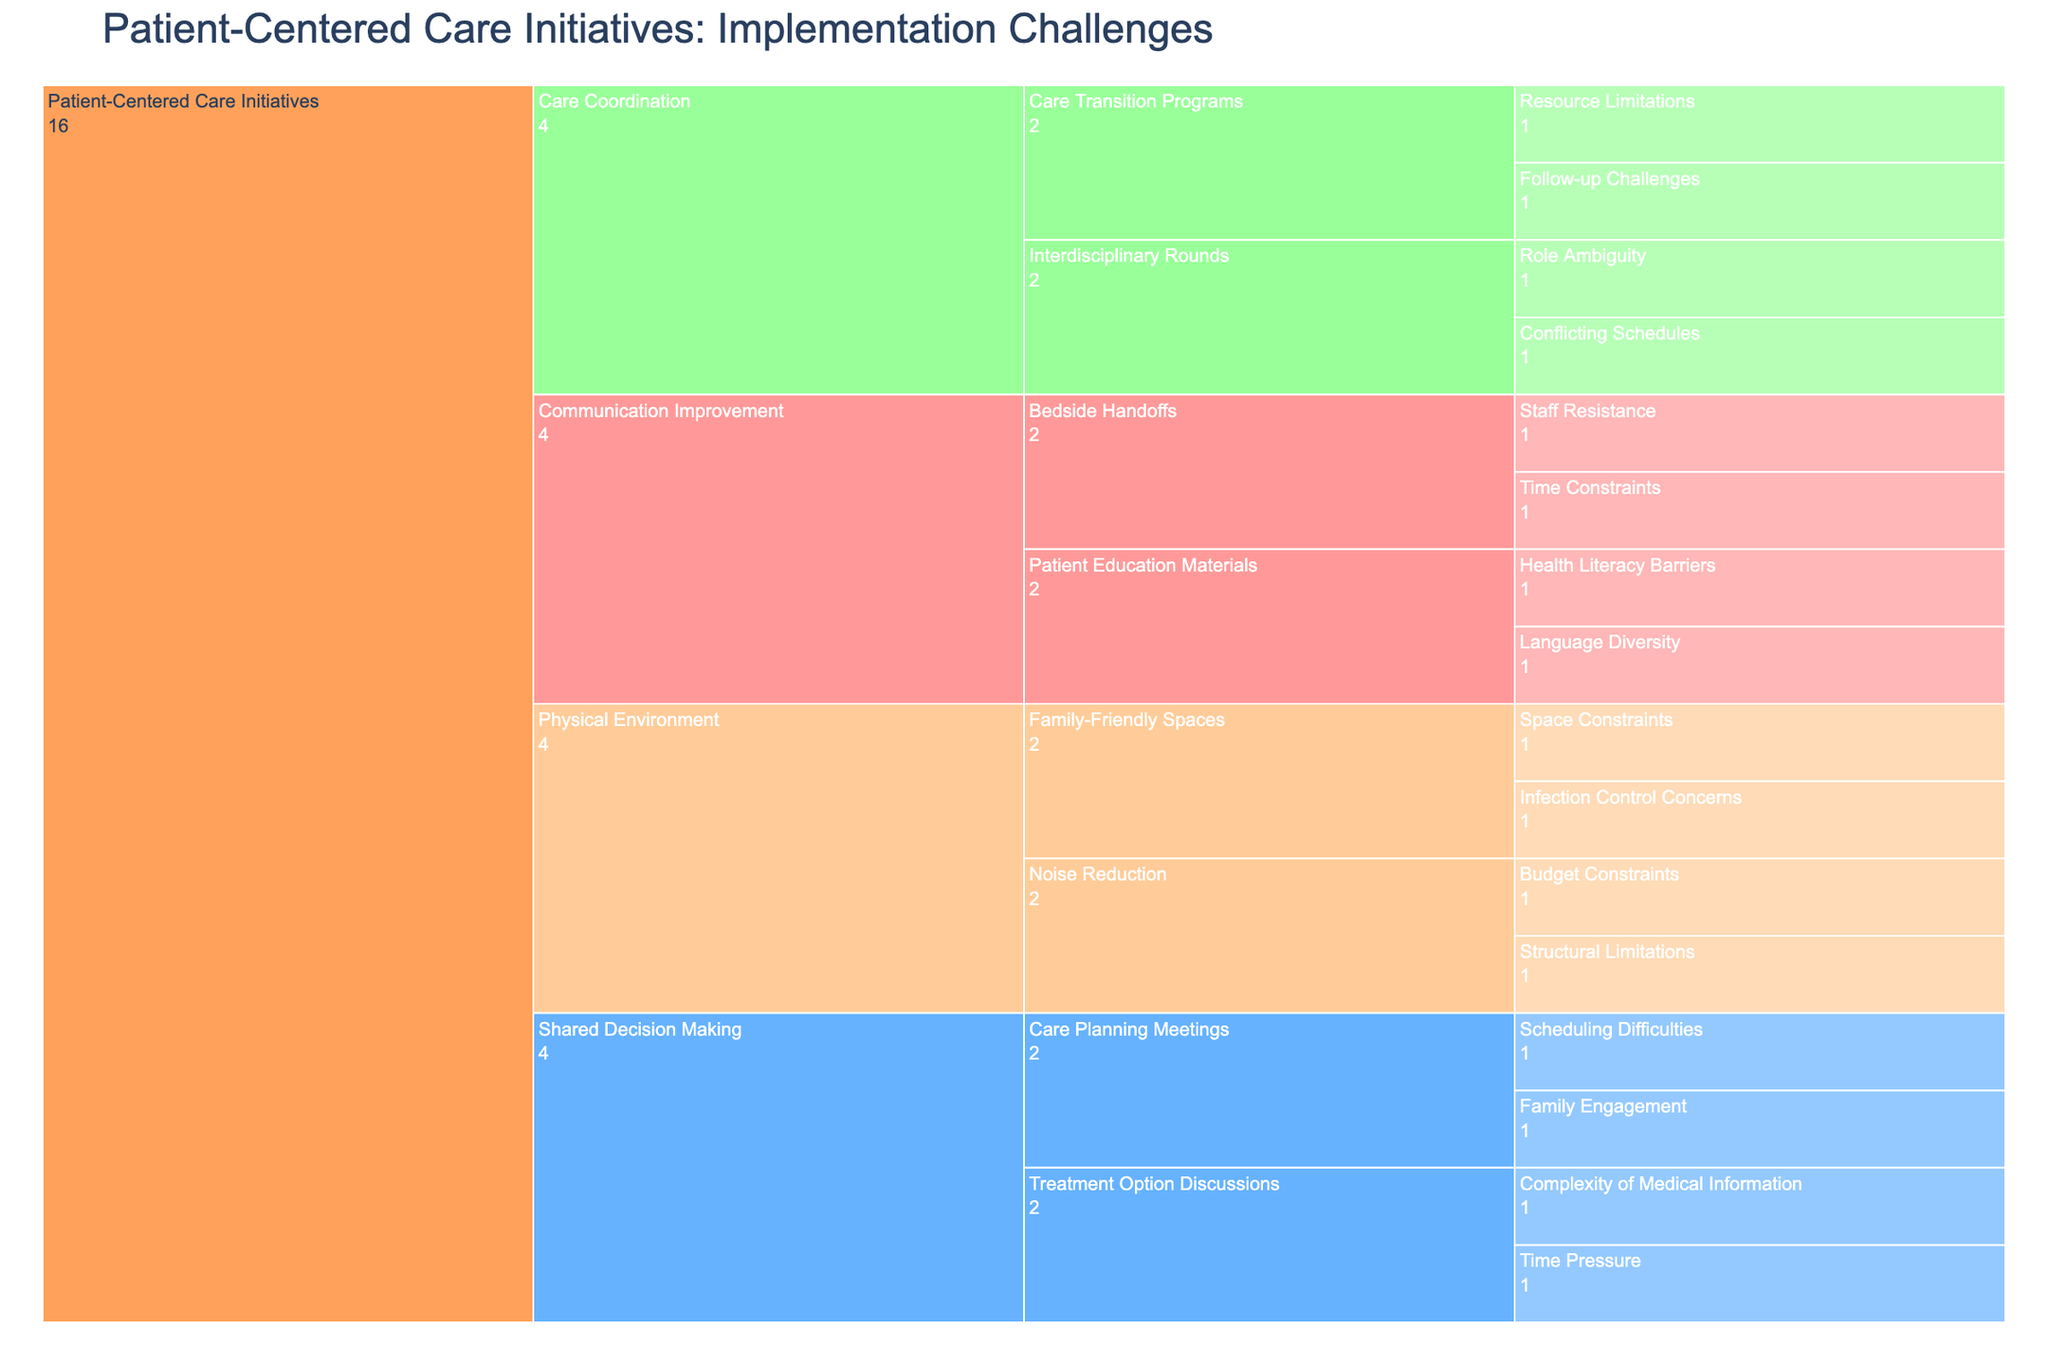What is the title of the chart? The title is displayed at the top of the chart.
Answer: Patient-Centered Care Initiatives: Implementation Challenges How many subcategories are listed under 'Communication Improvement'? Count the boxes under the 'Communication Improvement' section.
Answer: 2 Which category has 'Resource Limitations' as a challenge? Identify the challenge 'Resource Limitations' and trace its hierarchy.
Answer: Care Coordination How many challenges are listed under 'Care Coordination'? Count the number of boxes under the 'Care Coordination' section.
Answer: 4 Are there more challenges under 'Care Coordination' or 'Physical Environment'? Count the challenges in both sections and compare.
Answer: Care Coordination Which subcategory has 'Language Diversity' as a challenge? Identify the challenge 'Language Diversity' and trace its hierarchy.
Answer: Patient Education Materials What are the challenges listed under 'Interdisciplinary Rounds'? Look at all the boxes under the 'Interdisciplinary Rounds' subcategory.
Answer: Conflicting Schedules, Role Ambiguity Compare the number of challenges in 'Shared Decision Making' to 'Communication Improvement'. Count the challenges in both sections and compare their numbers.
Answer: Shared Decision Making has more Which subcategory in 'Shared Decision Making' deals with 'Complexity of Medical Information'? Identify the challenge 'Complexity of Medical Information' and trace its hierarchy.
Answer: Treatment Option Discussions Does 'Family-Friendly Spaces' face more or fewer challenges compared to 'Bedside Handoffs'? Count the challenges in both subcategories and compare.
Answer: Same number of challenges 